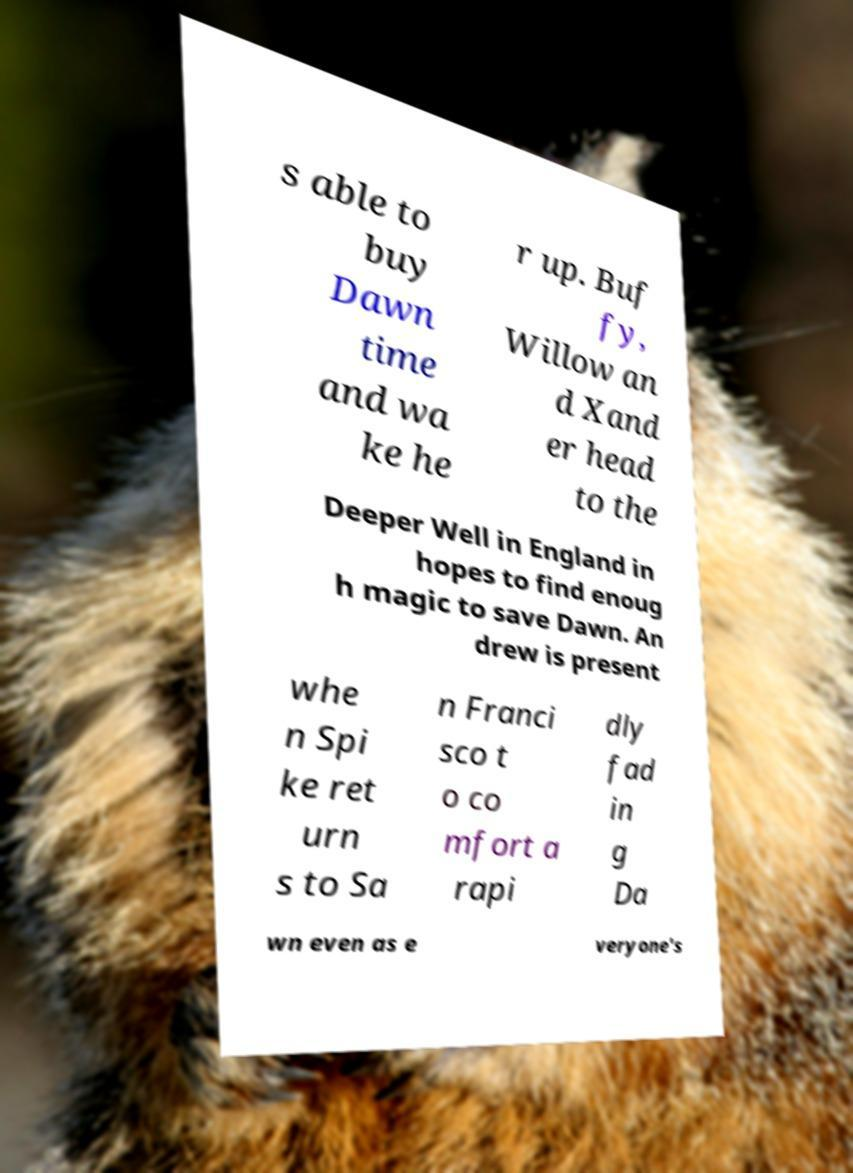Could you assist in decoding the text presented in this image and type it out clearly? s able to buy Dawn time and wa ke he r up. Buf fy, Willow an d Xand er head to the Deeper Well in England in hopes to find enoug h magic to save Dawn. An drew is present whe n Spi ke ret urn s to Sa n Franci sco t o co mfort a rapi dly fad in g Da wn even as e veryone's 